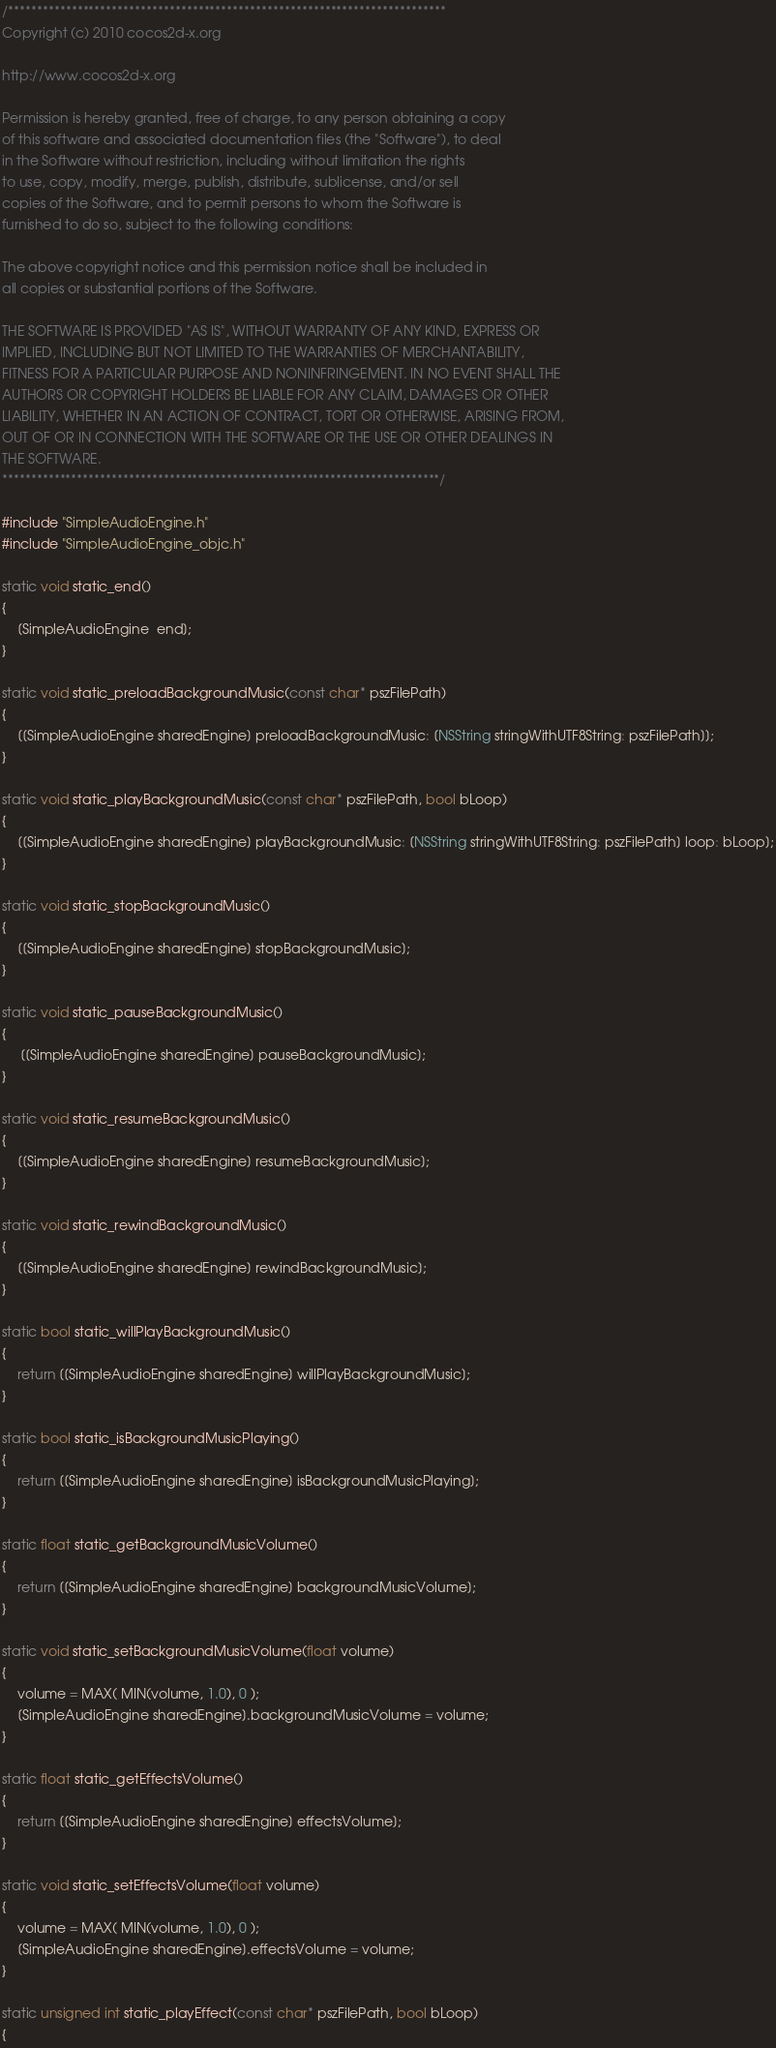<code> <loc_0><loc_0><loc_500><loc_500><_ObjectiveC_>/****************************************************************************
Copyright (c) 2010 cocos2d-x.org

http://www.cocos2d-x.org

Permission is hereby granted, free of charge, to any person obtaining a copy
of this software and associated documentation files (the "Software"), to deal
in the Software without restriction, including without limitation the rights
to use, copy, modify, merge, publish, distribute, sublicense, and/or sell
copies of the Software, and to permit persons to whom the Software is
furnished to do so, subject to the following conditions:

The above copyright notice and this permission notice shall be included in
all copies or substantial portions of the Software.

THE SOFTWARE IS PROVIDED "AS IS", WITHOUT WARRANTY OF ANY KIND, EXPRESS OR
IMPLIED, INCLUDING BUT NOT LIMITED TO THE WARRANTIES OF MERCHANTABILITY,
FITNESS FOR A PARTICULAR PURPOSE AND NONINFRINGEMENT. IN NO EVENT SHALL THE
AUTHORS OR COPYRIGHT HOLDERS BE LIABLE FOR ANY CLAIM, DAMAGES OR OTHER
LIABILITY, WHETHER IN AN ACTION OF CONTRACT, TORT OR OTHERWISE, ARISING FROM,
OUT OF OR IN CONNECTION WITH THE SOFTWARE OR THE USE OR OTHER DEALINGS IN
THE SOFTWARE.
****************************************************************************/

#include "SimpleAudioEngine.h"
#include "SimpleAudioEngine_objc.h"

static void static_end()
{
    [SimpleAudioEngine  end];
}

static void static_preloadBackgroundMusic(const char* pszFilePath)
{
    [[SimpleAudioEngine sharedEngine] preloadBackgroundMusic: [NSString stringWithUTF8String: pszFilePath]];
}

static void static_playBackgroundMusic(const char* pszFilePath, bool bLoop)
{
    [[SimpleAudioEngine sharedEngine] playBackgroundMusic: [NSString stringWithUTF8String: pszFilePath] loop: bLoop];
}

static void static_stopBackgroundMusic()
{
    [[SimpleAudioEngine sharedEngine] stopBackgroundMusic];
}

static void static_pauseBackgroundMusic()
{
     [[SimpleAudioEngine sharedEngine] pauseBackgroundMusic];
}

static void static_resumeBackgroundMusic()
{
    [[SimpleAudioEngine sharedEngine] resumeBackgroundMusic];
} 

static void static_rewindBackgroundMusic()
{
    [[SimpleAudioEngine sharedEngine] rewindBackgroundMusic];
}

static bool static_willPlayBackgroundMusic()
{
    return [[SimpleAudioEngine sharedEngine] willPlayBackgroundMusic];
}

static bool static_isBackgroundMusicPlaying()
{
    return [[SimpleAudioEngine sharedEngine] isBackgroundMusicPlaying];
}

static float static_getBackgroundMusicVolume()
{
    return [[SimpleAudioEngine sharedEngine] backgroundMusicVolume];
}

static void static_setBackgroundMusicVolume(float volume)
{
    volume = MAX( MIN(volume, 1.0), 0 );
    [SimpleAudioEngine sharedEngine].backgroundMusicVolume = volume;
}
     
static float static_getEffectsVolume()
{
    return [[SimpleAudioEngine sharedEngine] effectsVolume];
}
     
static void static_setEffectsVolume(float volume)
{
    volume = MAX( MIN(volume, 1.0), 0 );
    [SimpleAudioEngine sharedEngine].effectsVolume = volume;
}
     
static unsigned int static_playEffect(const char* pszFilePath, bool bLoop)
{</code> 